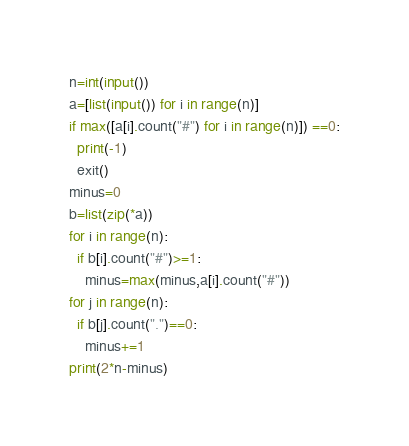<code> <loc_0><loc_0><loc_500><loc_500><_Python_>n=int(input())
a=[list(input()) for i in range(n)]
if max([a[i].count("#") for i in range(n)]) ==0:
  print(-1)
  exit()
minus=0
b=list(zip(*a))
for i in range(n):
  if b[i].count("#")>=1:
    minus=max(minus,a[i].count("#"))
for j in range(n):
  if b[j].count(".")==0:
    minus+=1
print(2*n-minus)</code> 